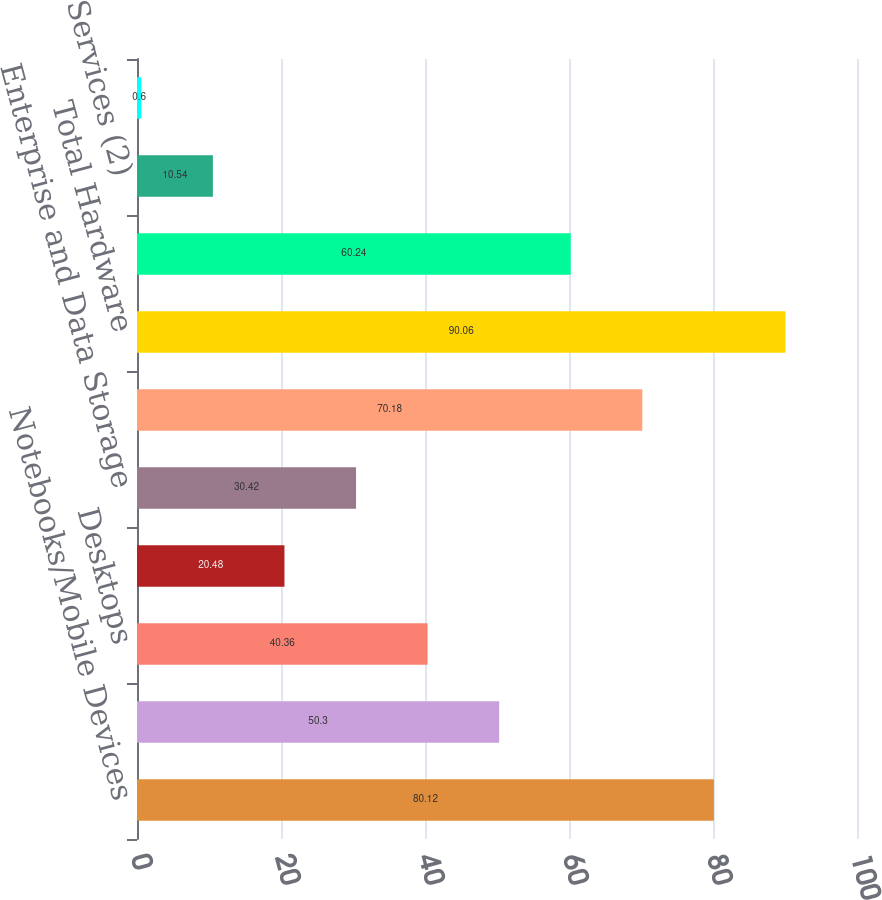Convert chart. <chart><loc_0><loc_0><loc_500><loc_500><bar_chart><fcel>Notebooks/Mobile Devices<fcel>Netcomm Products<fcel>Desktops<fcel>Video<fcel>Enterprise and Data Storage<fcel>Other Hardware<fcel>Total Hardware<fcel>Software<fcel>Services (2)<fcel>Other (3)<nl><fcel>80.12<fcel>50.3<fcel>40.36<fcel>20.48<fcel>30.42<fcel>70.18<fcel>90.06<fcel>60.24<fcel>10.54<fcel>0.6<nl></chart> 